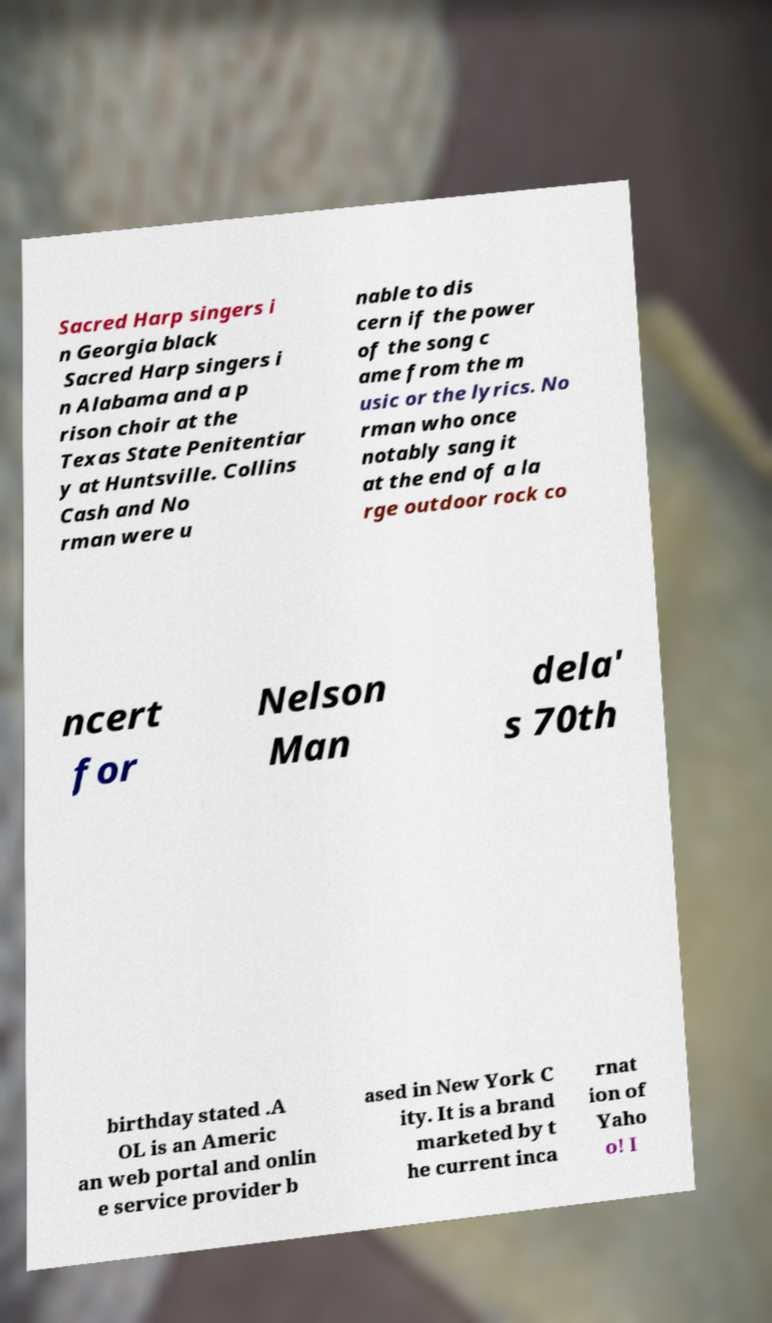What messages or text are displayed in this image? I need them in a readable, typed format. Sacred Harp singers i n Georgia black Sacred Harp singers i n Alabama and a p rison choir at the Texas State Penitentiar y at Huntsville. Collins Cash and No rman were u nable to dis cern if the power of the song c ame from the m usic or the lyrics. No rman who once notably sang it at the end of a la rge outdoor rock co ncert for Nelson Man dela' s 70th birthday stated .A OL is an Americ an web portal and onlin e service provider b ased in New York C ity. It is a brand marketed by t he current inca rnat ion of Yaho o! I 